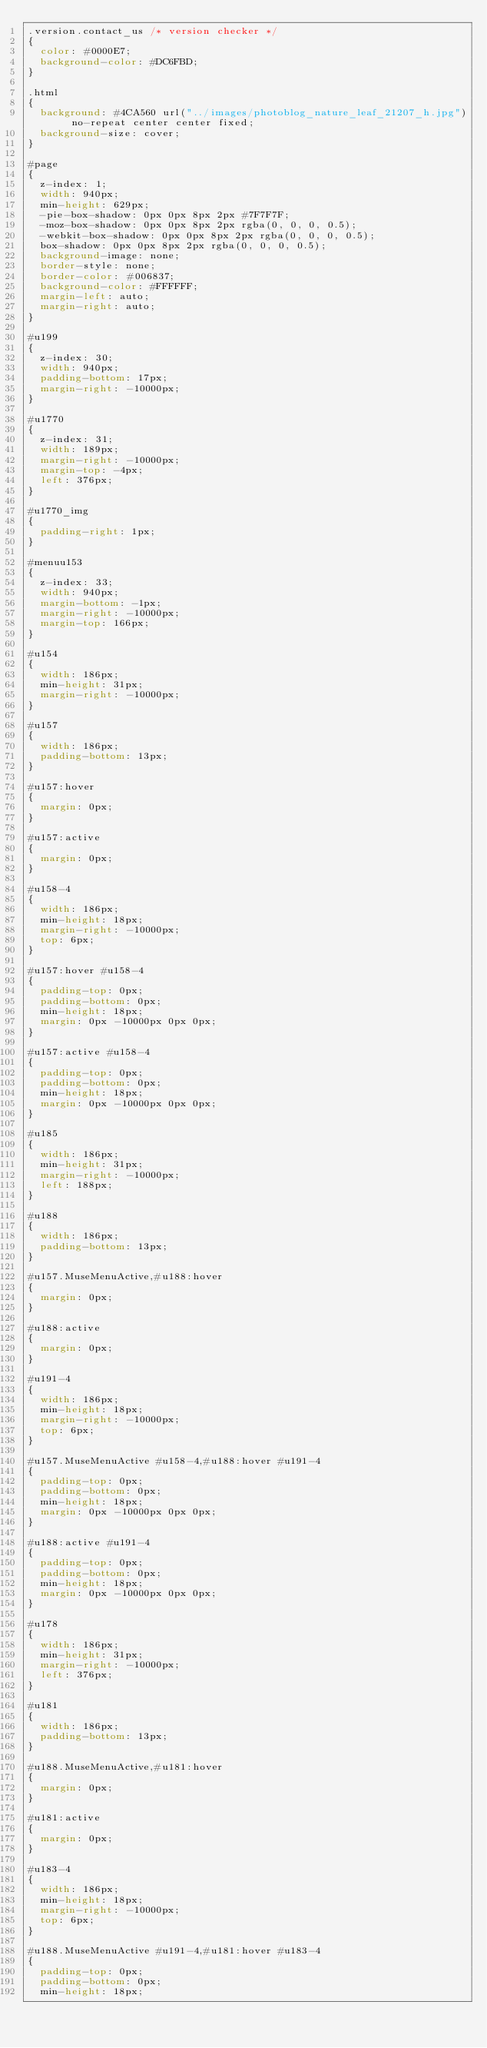Convert code to text. <code><loc_0><loc_0><loc_500><loc_500><_CSS_>.version.contact_us /* version checker */
{
	color: #0000E7;
	background-color: #DC6FBD;
}

.html
{
	background: #4CA560 url("../images/photoblog_nature_leaf_21207_h.jpg") no-repeat center center fixed;
	background-size: cover;
}

#page
{
	z-index: 1;
	width: 940px;
	min-height: 629px;
	-pie-box-shadow: 0px 0px 8px 2px #7F7F7F;
	-moz-box-shadow: 0px 0px 8px 2px rgba(0, 0, 0, 0.5);
	-webkit-box-shadow: 0px 0px 8px 2px rgba(0, 0, 0, 0.5);
	box-shadow: 0px 0px 8px 2px rgba(0, 0, 0, 0.5);
	background-image: none;
	border-style: none;
	border-color: #006837;
	background-color: #FFFFFF;
	margin-left: auto;
	margin-right: auto;
}

#u199
{
	z-index: 30;
	width: 940px;
	padding-bottom: 17px;
	margin-right: -10000px;
}

#u1770
{
	z-index: 31;
	width: 189px;
	margin-right: -10000px;
	margin-top: -4px;
	left: 376px;
}

#u1770_img
{
	padding-right: 1px;
}

#menuu153
{
	z-index: 33;
	width: 940px;
	margin-bottom: -1px;
	margin-right: -10000px;
	margin-top: 166px;
}

#u154
{
	width: 186px;
	min-height: 31px;
	margin-right: -10000px;
}

#u157
{
	width: 186px;
	padding-bottom: 13px;
}

#u157:hover
{
	margin: 0px;
}

#u157:active
{
	margin: 0px;
}

#u158-4
{
	width: 186px;
	min-height: 18px;
	margin-right: -10000px;
	top: 6px;
}

#u157:hover #u158-4
{
	padding-top: 0px;
	padding-bottom: 0px;
	min-height: 18px;
	margin: 0px -10000px 0px 0px;
}

#u157:active #u158-4
{
	padding-top: 0px;
	padding-bottom: 0px;
	min-height: 18px;
	margin: 0px -10000px 0px 0px;
}

#u185
{
	width: 186px;
	min-height: 31px;
	margin-right: -10000px;
	left: 188px;
}

#u188
{
	width: 186px;
	padding-bottom: 13px;
}

#u157.MuseMenuActive,#u188:hover
{
	margin: 0px;
}

#u188:active
{
	margin: 0px;
}

#u191-4
{
	width: 186px;
	min-height: 18px;
	margin-right: -10000px;
	top: 6px;
}

#u157.MuseMenuActive #u158-4,#u188:hover #u191-4
{
	padding-top: 0px;
	padding-bottom: 0px;
	min-height: 18px;
	margin: 0px -10000px 0px 0px;
}

#u188:active #u191-4
{
	padding-top: 0px;
	padding-bottom: 0px;
	min-height: 18px;
	margin: 0px -10000px 0px 0px;
}

#u178
{
	width: 186px;
	min-height: 31px;
	margin-right: -10000px;
	left: 376px;
}

#u181
{
	width: 186px;
	padding-bottom: 13px;
}

#u188.MuseMenuActive,#u181:hover
{
	margin: 0px;
}

#u181:active
{
	margin: 0px;
}

#u183-4
{
	width: 186px;
	min-height: 18px;
	margin-right: -10000px;
	top: 6px;
}

#u188.MuseMenuActive #u191-4,#u181:hover #u183-4
{
	padding-top: 0px;
	padding-bottom: 0px;
	min-height: 18px;</code> 